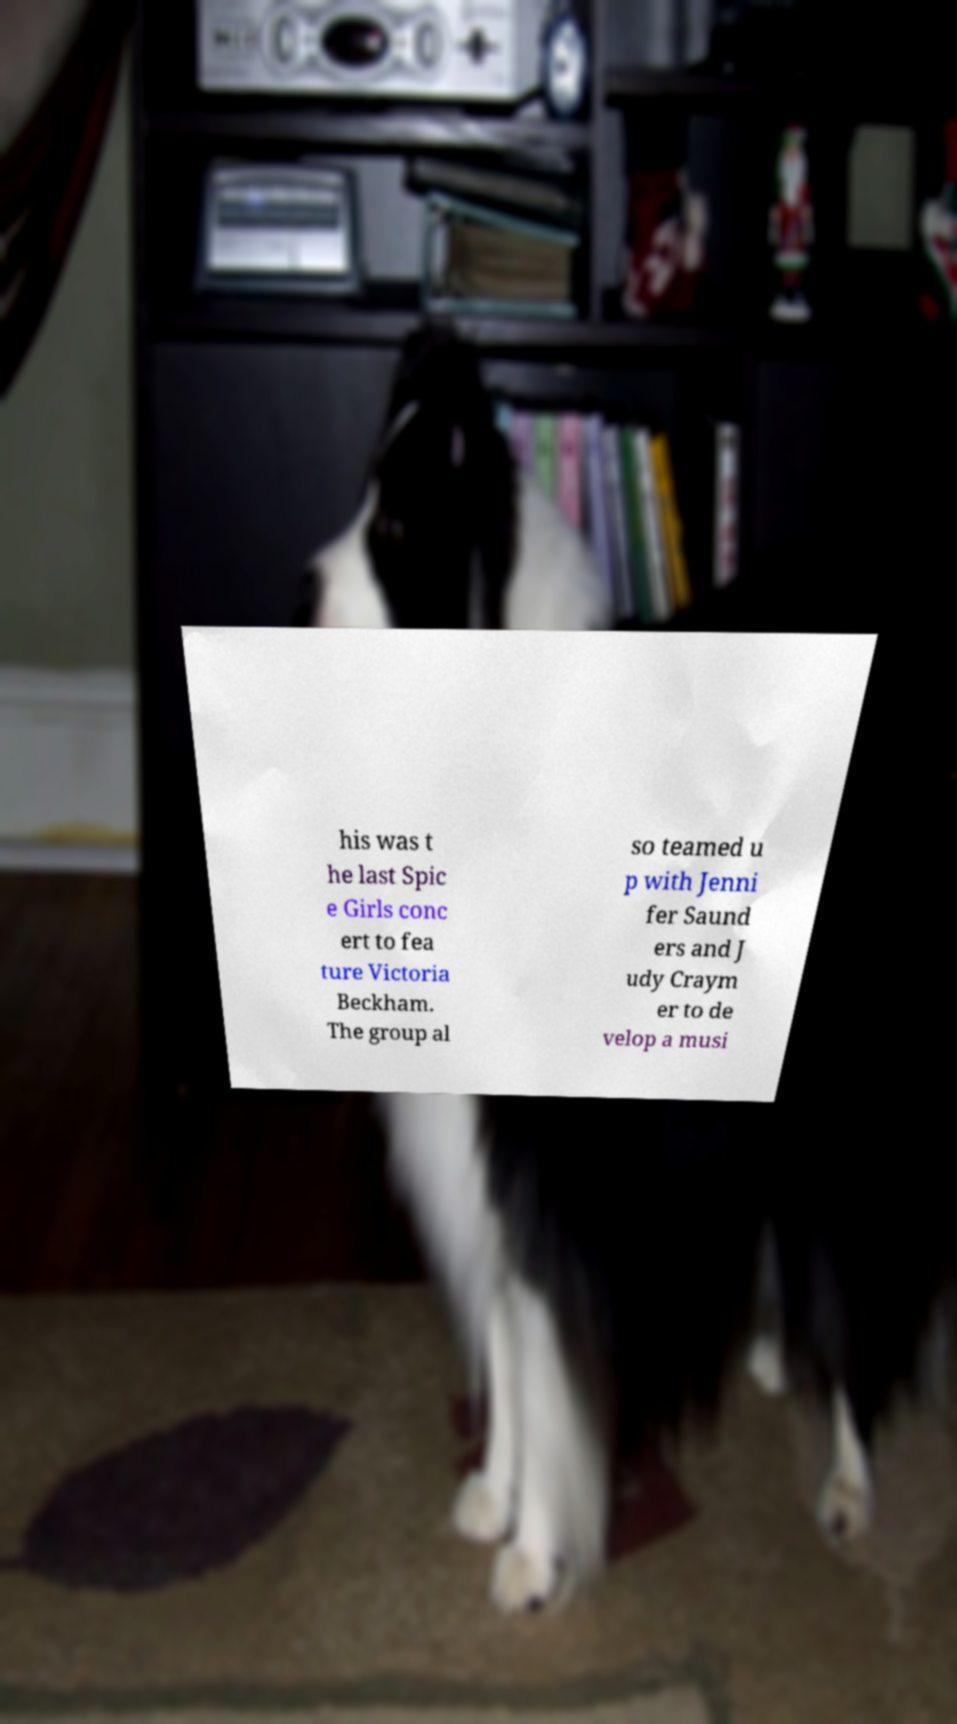What messages or text are displayed in this image? I need them in a readable, typed format. his was t he last Spic e Girls conc ert to fea ture Victoria Beckham. The group al so teamed u p with Jenni fer Saund ers and J udy Craym er to de velop a musi 